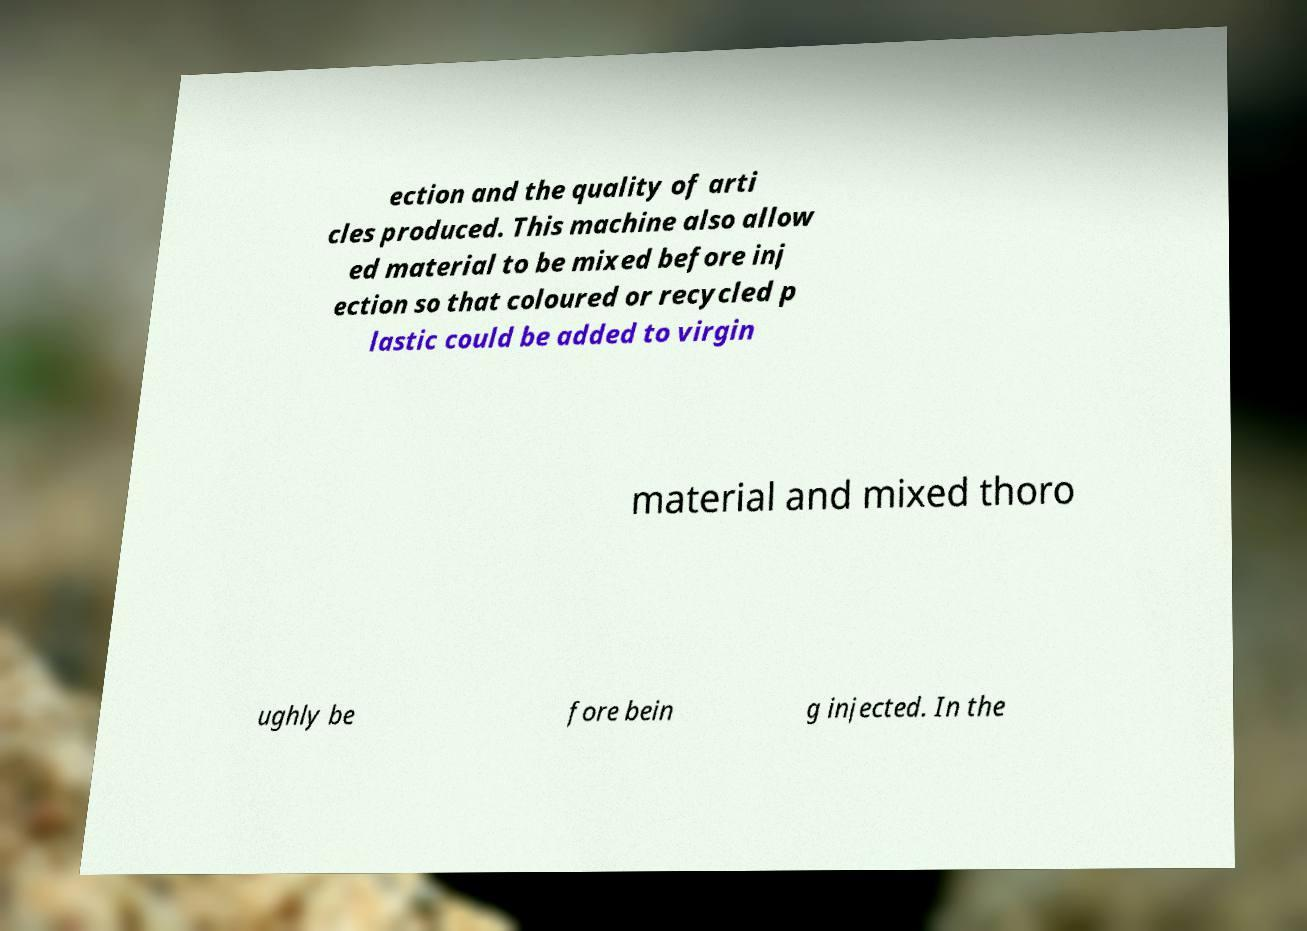Please read and relay the text visible in this image. What does it say? ection and the quality of arti cles produced. This machine also allow ed material to be mixed before inj ection so that coloured or recycled p lastic could be added to virgin material and mixed thoro ughly be fore bein g injected. In the 